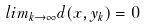<formula> <loc_0><loc_0><loc_500><loc_500>l i m _ { k \rightarrow \infty } d ( x , y _ { k } ) = 0</formula> 